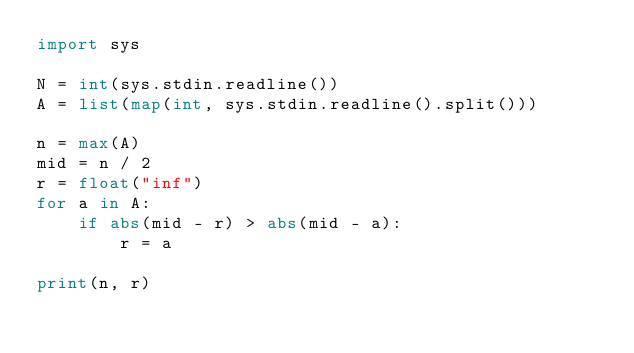<code> <loc_0><loc_0><loc_500><loc_500><_Python_>import sys

N = int(sys.stdin.readline())
A = list(map(int, sys.stdin.readline().split()))

n = max(A)
mid = n / 2
r = float("inf")
for a in A:
    if abs(mid - r) > abs(mid - a):
        r = a

print(n, r)</code> 